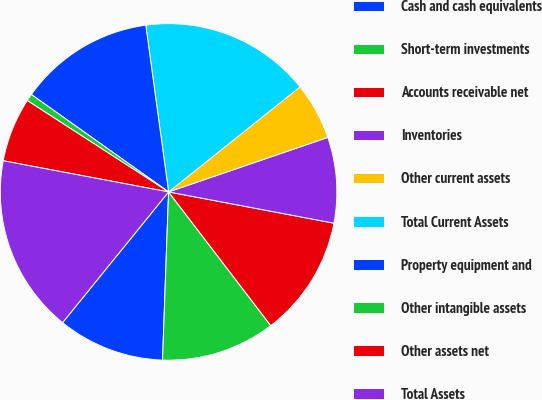<chart> <loc_0><loc_0><loc_500><loc_500><pie_chart><fcel>Cash and cash equivalents<fcel>Short-term investments<fcel>Accounts receivable net<fcel>Inventories<fcel>Other current assets<fcel>Total Current Assets<fcel>Property equipment and<fcel>Other intangible assets<fcel>Other assets net<fcel>Total Assets<nl><fcel>10.27%<fcel>10.96%<fcel>11.64%<fcel>8.22%<fcel>5.48%<fcel>16.44%<fcel>13.01%<fcel>0.69%<fcel>6.17%<fcel>17.12%<nl></chart> 